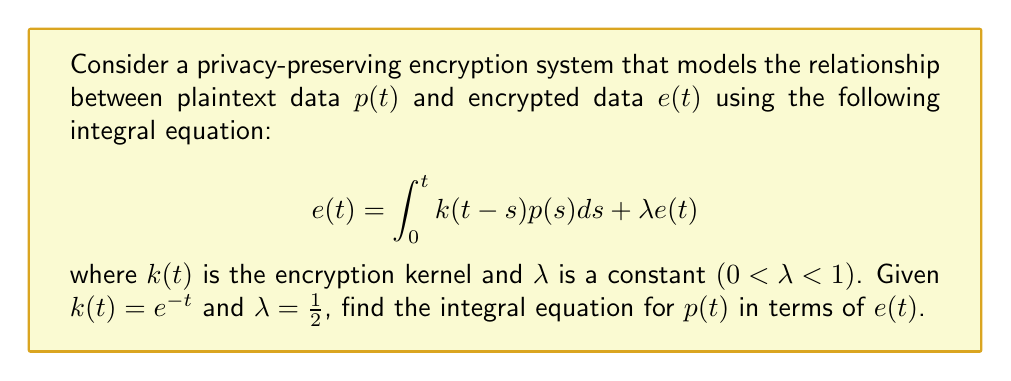Teach me how to tackle this problem. To solve this integral equation and express $p(t)$ in terms of $e(t)$, we'll follow these steps:

1) First, rearrange the original equation to isolate the integral term:
   $$\int_0^t k(t-s)p(s)ds = e(t) - \lambda e(t) = (1-\lambda)e(t)$$

2) Given $\lambda = \frac{1}{2}$, substitute this value:
   $$\int_0^t k(t-s)p(s)ds = \frac{1}{2}e(t)$$

3) Now, we need to apply the convolution theorem. The Laplace transform of a convolution is the product of the Laplace transforms of the individual functions. Let's denote the Laplace transform with $\mathcal{L}$. Taking the Laplace transform of both sides:
   $$\mathcal{L}\left\{\int_0^t k(t-s)p(s)ds\right\} = \mathcal{L}\left\{\frac{1}{2}e(t)\right\}$$

4) Using the convolution theorem:
   $$\mathcal{L}\{k(t)\} \cdot \mathcal{L}\{p(t)\} = \frac{1}{2}\mathcal{L}\{e(t)\}$$

5) Let $P(s)$, $E(s)$, and $K(s)$ be the Laplace transforms of $p(t)$, $e(t)$, and $k(t)$ respectively. We can rewrite:
   $$K(s) \cdot P(s) = \frac{1}{2}E(s)$$

6) Now, we need to find $K(s)$. Given $k(t) = e^{-t}$, its Laplace transform is:
   $$K(s) = \mathcal{L}\{e^{-t}\} = \frac{1}{s+1}$$

7) Substituting this into our equation:
   $$\frac{1}{s+1} \cdot P(s) = \frac{1}{2}E(s)$$

8) Solve for $P(s)$:
   $$P(s) = \frac{1}{2}(s+1)E(s)$$

9) Now, we need to take the inverse Laplace transform of both sides to get back to the time domain. The inverse Laplace transform of $sE(s)$ is $\frac{d}{dt}e(t)$, so:
   $$p(t) = \frac{1}{2}\left(\frac{d}{dt}e(t) + e(t)\right)$$

This is our final integral equation expressing $p(t)$ in terms of $e(t)$.
Answer: $$p(t) = \frac{1}{2}\left(\frac{d}{dt}e(t) + e(t)\right)$$ 